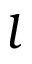<formula> <loc_0><loc_0><loc_500><loc_500>l</formula> 